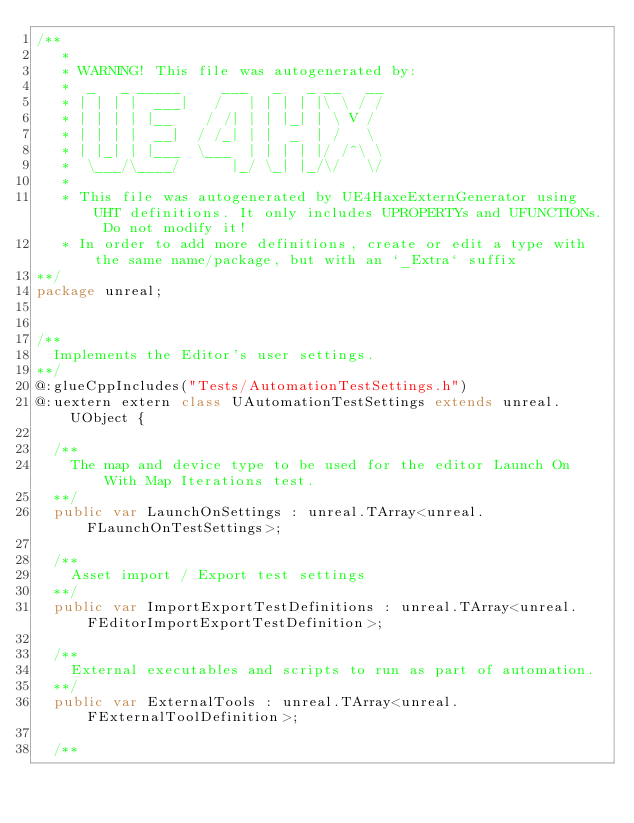Convert code to text. <code><loc_0><loc_0><loc_500><loc_500><_Haxe_>/**
   * 
   * WARNING! This file was autogenerated by: 
   *  _   _ _____     ___   _   _ __   __ 
   * | | | |  ___|   /   | | | | |\ \ / / 
   * | | | | |__    / /| | | |_| | \ V /  
   * | | | |  __|  / /_| | |  _  | /   \  
   * | |_| | |___  \___  | | | | |/ /^\ \ 
   *  \___/\____/      |_/ \_| |_/\/   \/ 
   * 
   * This file was autogenerated by UE4HaxeExternGenerator using UHT definitions. It only includes UPROPERTYs and UFUNCTIONs. Do not modify it!
   * In order to add more definitions, create or edit a type with the same name/package, but with an `_Extra` suffix
**/
package unreal;


/**
  Implements the Editor's user settings.
**/
@:glueCppIncludes("Tests/AutomationTestSettings.h")
@:uextern extern class UAutomationTestSettings extends unreal.UObject {
  
  /**
    The map and device type to be used for the editor Launch On With Map Iterations test.
  **/
  public var LaunchOnSettings : unreal.TArray<unreal.FLaunchOnTestSettings>;
  
  /**
    Asset import / Export test settings
  **/
  public var ImportExportTestDefinitions : unreal.TArray<unreal.FEditorImportExportTestDefinition>;
  
  /**
    External executables and scripts to run as part of automation.
  **/
  public var ExternalTools : unreal.TArray<unreal.FExternalToolDefinition>;
  
  /**</code> 